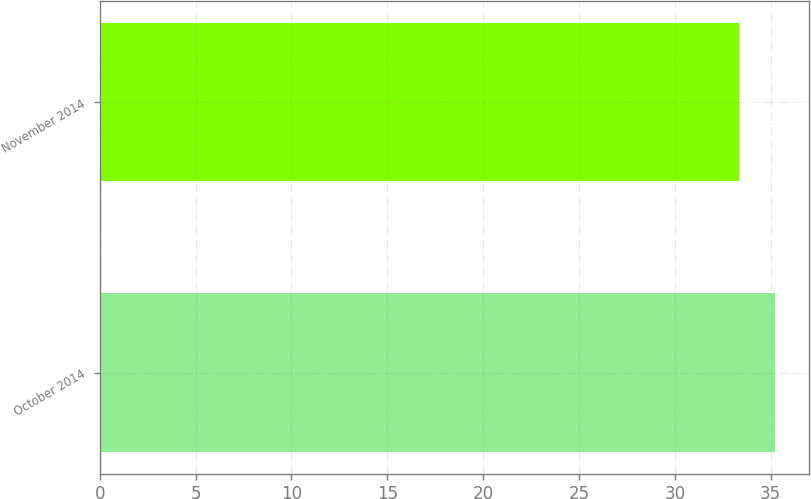Convert chart to OTSL. <chart><loc_0><loc_0><loc_500><loc_500><bar_chart><fcel>October 2014<fcel>November 2014<nl><fcel>35.22<fcel>33.36<nl></chart> 